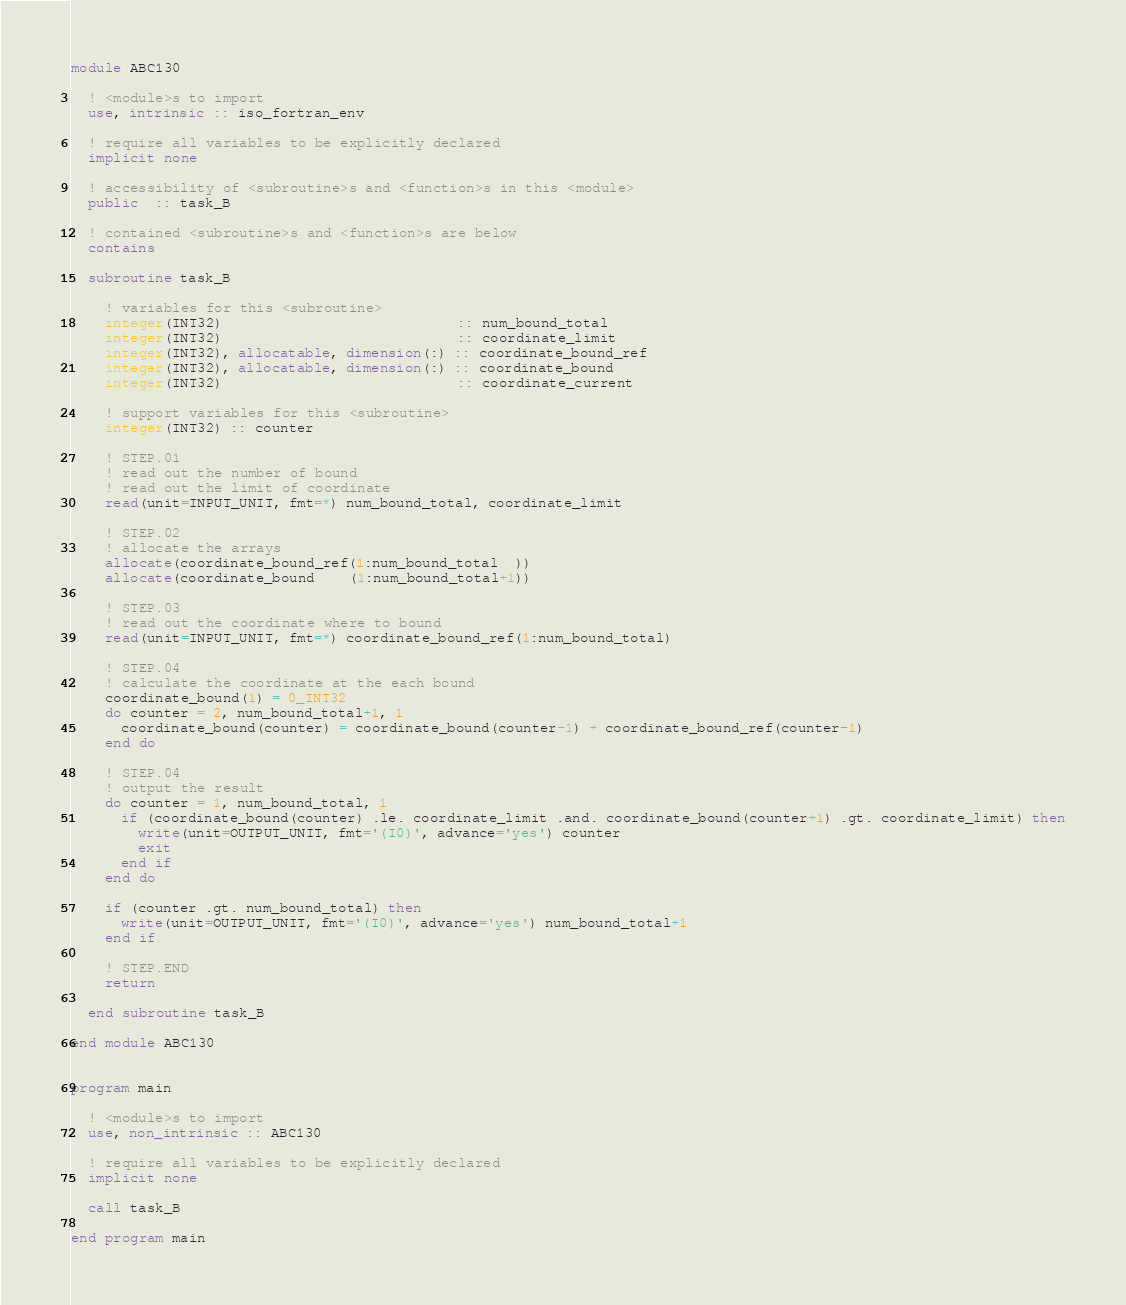Convert code to text. <code><loc_0><loc_0><loc_500><loc_500><_FORTRAN_>module ABC130

  ! <module>s to import
  use, intrinsic :: iso_fortran_env

  ! require all variables to be explicitly declared
  implicit none

  ! accessibility of <subroutine>s and <function>s in this <module>
  public  :: task_B

  ! contained <subroutine>s and <function>s are below
  contains

  subroutine task_B

    ! variables for this <subroutine>
    integer(INT32)                            :: num_bound_total
    integer(INT32)                            :: coordinate_limit
    integer(INT32), allocatable, dimension(:) :: coordinate_bound_ref
    integer(INT32), allocatable, dimension(:) :: coordinate_bound
    integer(INT32)                            :: coordinate_current

    ! support variables for this <subroutine>
    integer(INT32) :: counter

    ! STEP.01
    ! read out the number of bound
    ! read out the limit of coordinate
    read(unit=INPUT_UNIT, fmt=*) num_bound_total, coordinate_limit

    ! STEP.02
    ! allocate the arrays
    allocate(coordinate_bound_ref(1:num_bound_total  ))
    allocate(coordinate_bound    (1:num_bound_total+1))

    ! STEP.03
    ! read out the coordinate where to bound
    read(unit=INPUT_UNIT, fmt=*) coordinate_bound_ref(1:num_bound_total)

    ! STEP.04
    ! calculate the coordinate at the each bound
    coordinate_bound(1) = 0_INT32
    do counter = 2, num_bound_total+1, 1
      coordinate_bound(counter) = coordinate_bound(counter-1) + coordinate_bound_ref(counter-1)
    end do

    ! STEP.04
    ! output the result
    do counter = 1, num_bound_total, 1
      if (coordinate_bound(counter) .le. coordinate_limit .and. coordinate_bound(counter+1) .gt. coordinate_limit) then
        write(unit=OUTPUT_UNIT, fmt='(I0)', advance='yes') counter
        exit
      end if
    end do

    if (counter .gt. num_bound_total) then
      write(unit=OUTPUT_UNIT, fmt='(I0)', advance='yes') num_bound_total+1
    end if

    ! STEP.END
    return

  end subroutine task_B

end module ABC130


program main

  ! <module>s to import
  use, non_intrinsic :: ABC130

  ! require all variables to be explicitly declared
  implicit none

  call task_B

end program main</code> 